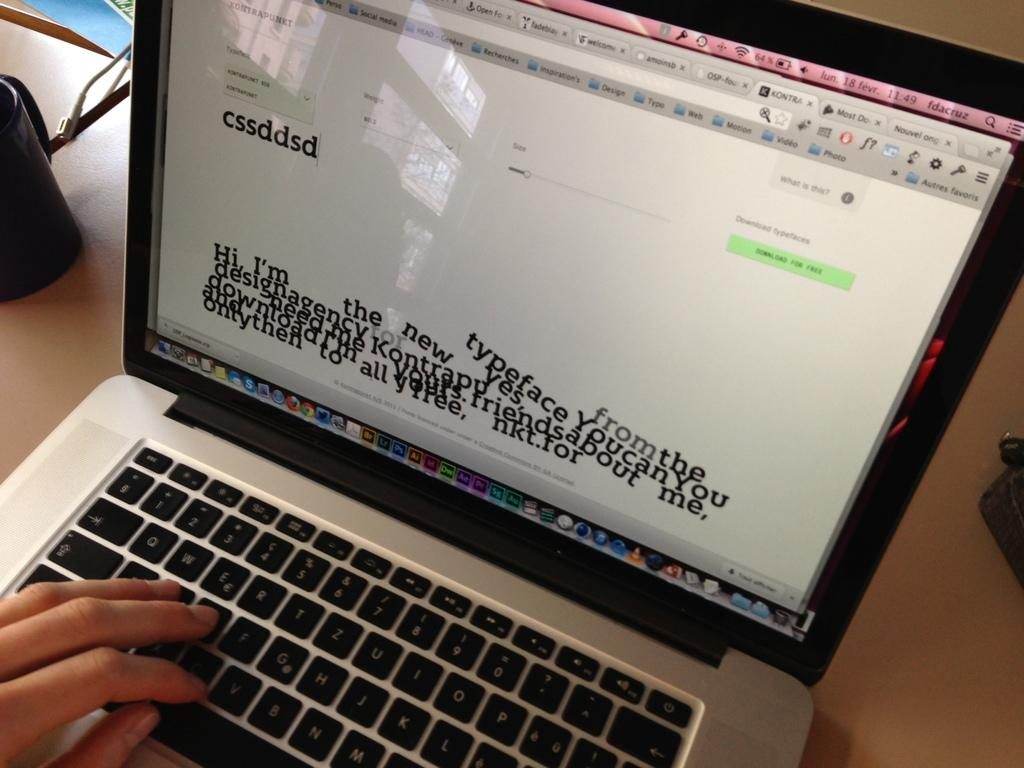Provide a one-sentence caption for the provided image. A laptop screen shows a new typeface that you can download for free. 